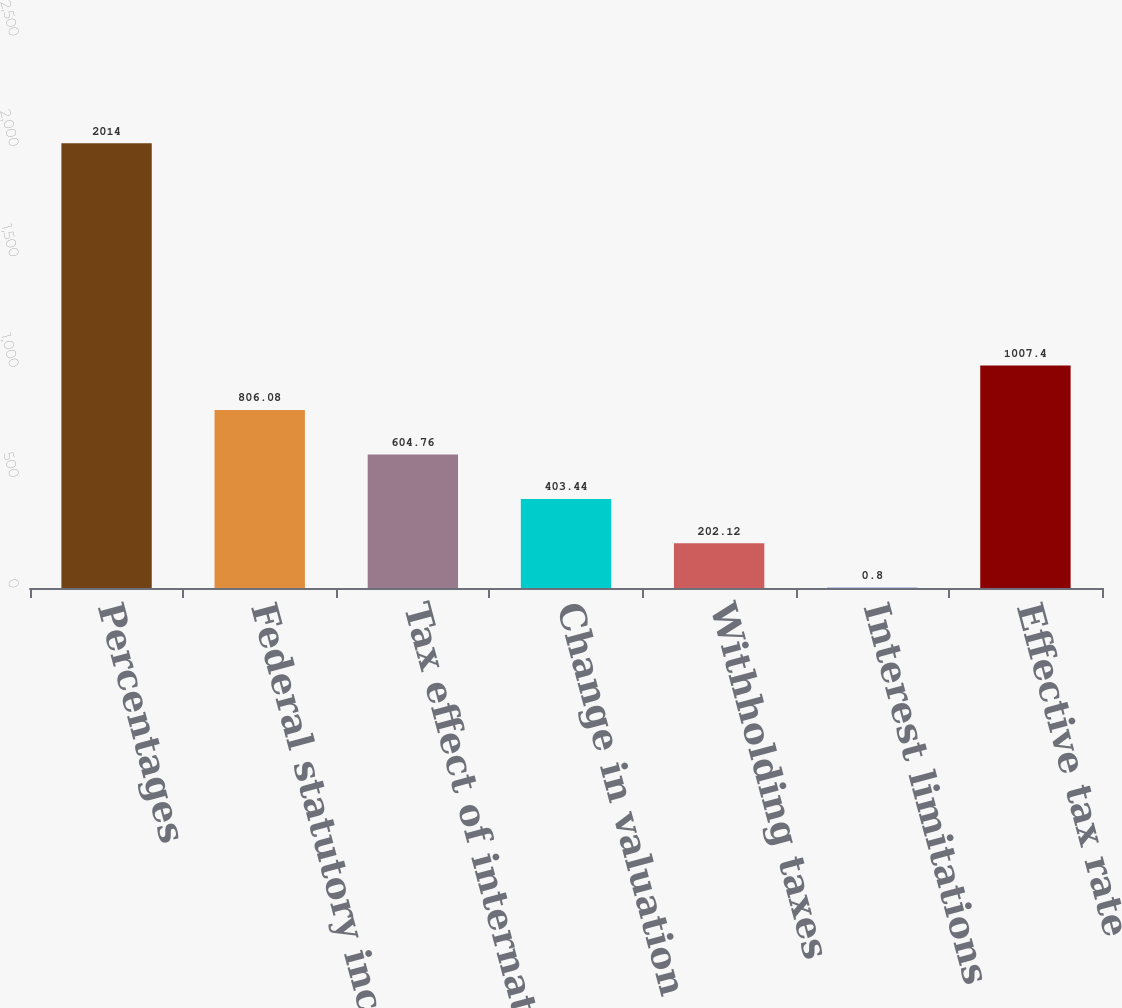<chart> <loc_0><loc_0><loc_500><loc_500><bar_chart><fcel>Percentages<fcel>Federal statutory income tax<fcel>Tax effect of international<fcel>Change in valuation allowances<fcel>Withholding taxes<fcel>Interest limitations<fcel>Effective tax rate<nl><fcel>2014<fcel>806.08<fcel>604.76<fcel>403.44<fcel>202.12<fcel>0.8<fcel>1007.4<nl></chart> 